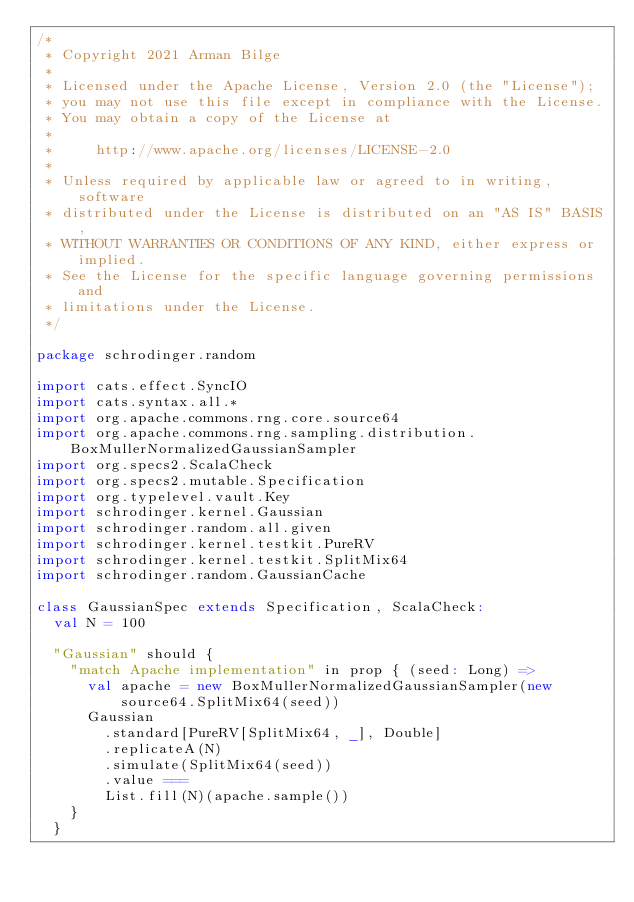Convert code to text. <code><loc_0><loc_0><loc_500><loc_500><_Scala_>/*
 * Copyright 2021 Arman Bilge
 *
 * Licensed under the Apache License, Version 2.0 (the "License");
 * you may not use this file except in compliance with the License.
 * You may obtain a copy of the License at
 *
 *     http://www.apache.org/licenses/LICENSE-2.0
 *
 * Unless required by applicable law or agreed to in writing, software
 * distributed under the License is distributed on an "AS IS" BASIS,
 * WITHOUT WARRANTIES OR CONDITIONS OF ANY KIND, either express or implied.
 * See the License for the specific language governing permissions and
 * limitations under the License.
 */

package schrodinger.random

import cats.effect.SyncIO
import cats.syntax.all.*
import org.apache.commons.rng.core.source64
import org.apache.commons.rng.sampling.distribution.BoxMullerNormalizedGaussianSampler
import org.specs2.ScalaCheck
import org.specs2.mutable.Specification
import org.typelevel.vault.Key
import schrodinger.kernel.Gaussian
import schrodinger.random.all.given
import schrodinger.kernel.testkit.PureRV
import schrodinger.kernel.testkit.SplitMix64
import schrodinger.random.GaussianCache

class GaussianSpec extends Specification, ScalaCheck:
  val N = 100

  "Gaussian" should {
    "match Apache implementation" in prop { (seed: Long) =>
      val apache = new BoxMullerNormalizedGaussianSampler(new source64.SplitMix64(seed))
      Gaussian
        .standard[PureRV[SplitMix64, _], Double]
        .replicateA(N)
        .simulate(SplitMix64(seed))
        .value ===
        List.fill(N)(apache.sample())
    }
  }
</code> 